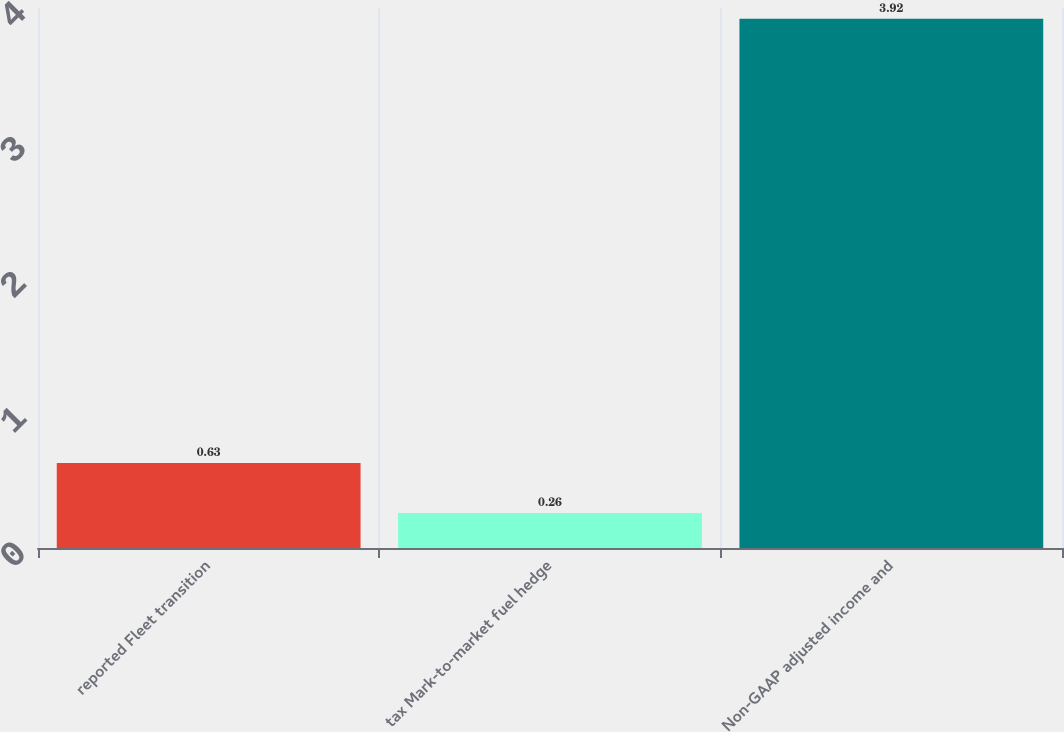Convert chart. <chart><loc_0><loc_0><loc_500><loc_500><bar_chart><fcel>reported Fleet transition<fcel>tax Mark-to-market fuel hedge<fcel>Non-GAAP adjusted income and<nl><fcel>0.63<fcel>0.26<fcel>3.92<nl></chart> 